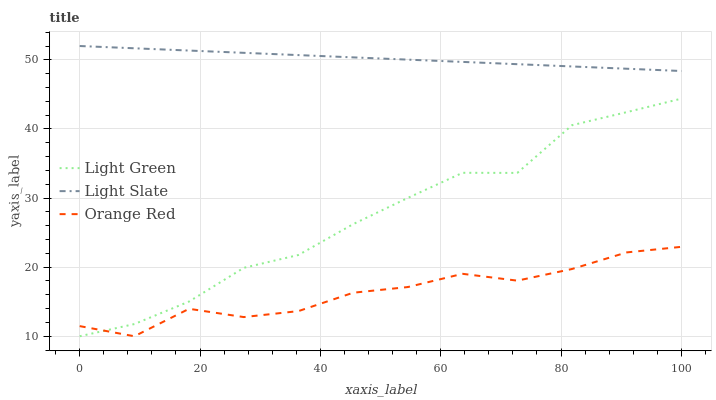Does Orange Red have the minimum area under the curve?
Answer yes or no. Yes. Does Light Slate have the maximum area under the curve?
Answer yes or no. Yes. Does Light Green have the minimum area under the curve?
Answer yes or no. No. Does Light Green have the maximum area under the curve?
Answer yes or no. No. Is Light Slate the smoothest?
Answer yes or no. Yes. Is Orange Red the roughest?
Answer yes or no. Yes. Is Light Green the smoothest?
Answer yes or no. No. Is Light Green the roughest?
Answer yes or no. No. Does Orange Red have the lowest value?
Answer yes or no. Yes. Does Light Slate have the highest value?
Answer yes or no. Yes. Does Light Green have the highest value?
Answer yes or no. No. Is Light Green less than Light Slate?
Answer yes or no. Yes. Is Light Slate greater than Light Green?
Answer yes or no. Yes. Does Light Green intersect Orange Red?
Answer yes or no. Yes. Is Light Green less than Orange Red?
Answer yes or no. No. Is Light Green greater than Orange Red?
Answer yes or no. No. Does Light Green intersect Light Slate?
Answer yes or no. No. 